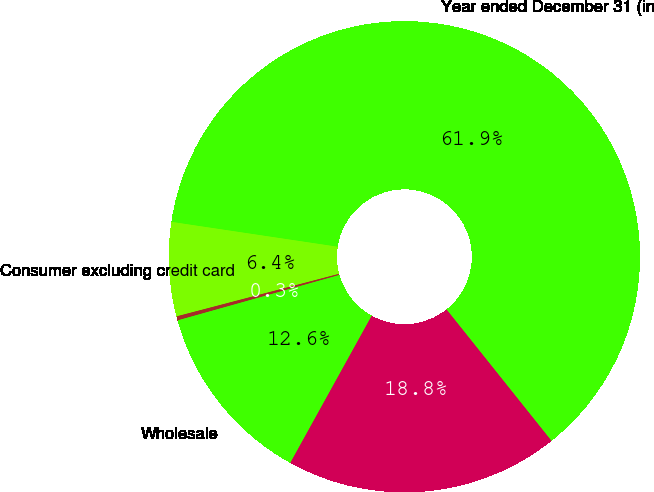<chart> <loc_0><loc_0><loc_500><loc_500><pie_chart><fcel>Year ended December 31 (in<fcel>Consumer excluding credit card<fcel>Credit card<fcel>Wholesale<fcel>Total net gains/(losses) on<nl><fcel>61.91%<fcel>6.44%<fcel>0.28%<fcel>12.6%<fcel>18.77%<nl></chart> 